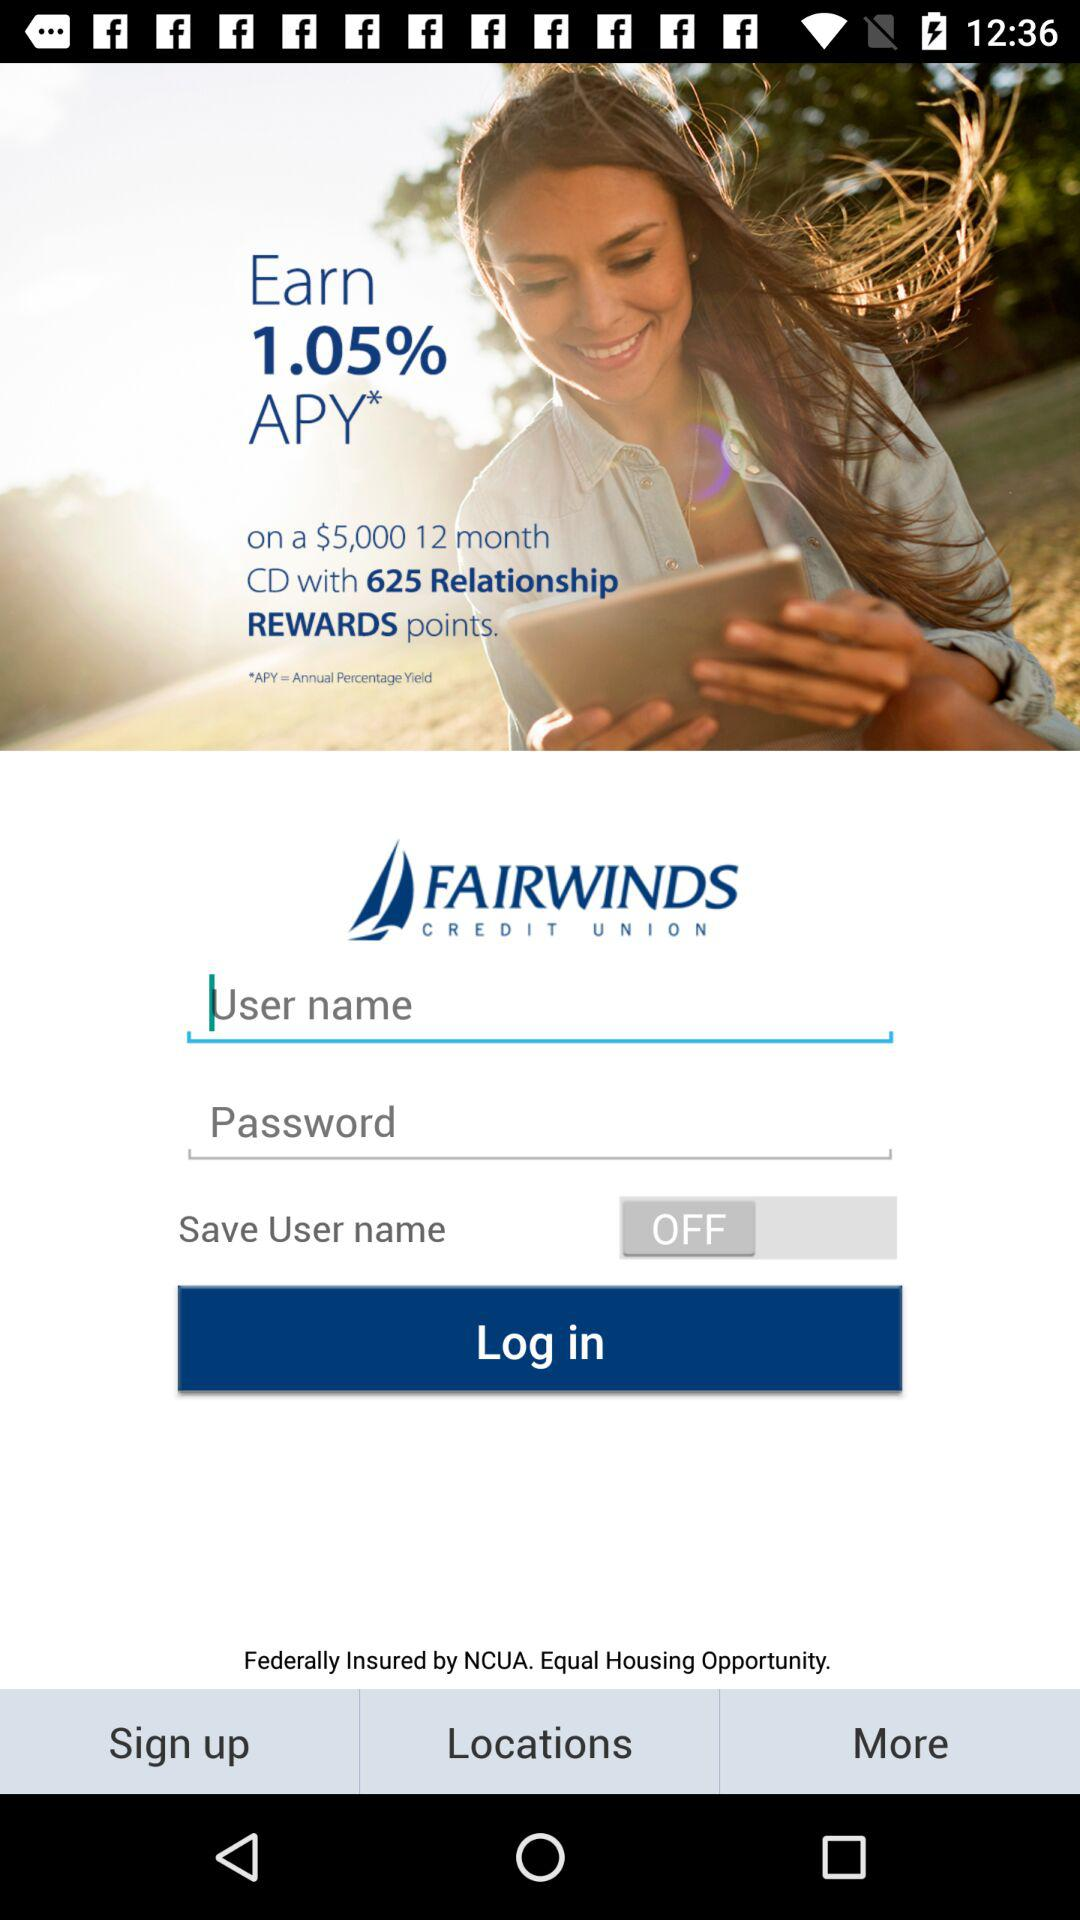What is the annual yield percentage to earn? The annual yield percentage to earn is 1.05%. 